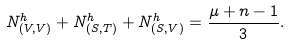<formula> <loc_0><loc_0><loc_500><loc_500>N _ { ( V , V ) } ^ { h } + N _ { ( S , T ) } ^ { h } + N _ { ( S , V ) } ^ { h } = \frac { \mu + n - 1 } { 3 } .</formula> 